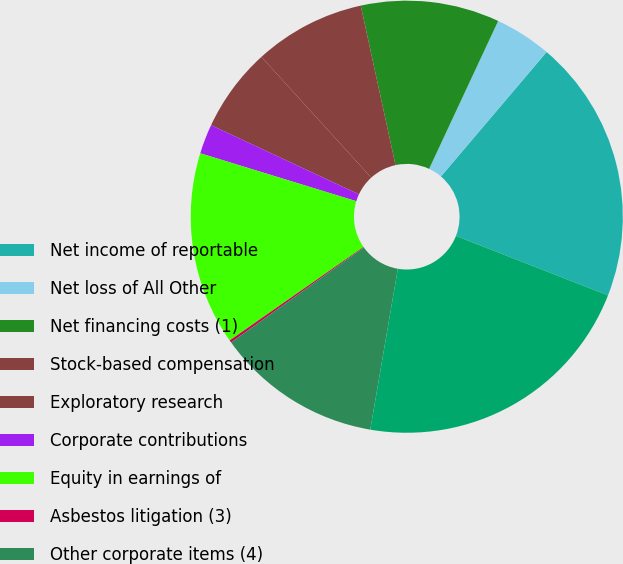<chart> <loc_0><loc_0><loc_500><loc_500><pie_chart><fcel>Net income of reportable<fcel>Net loss of All Other<fcel>Net financing costs (1)<fcel>Stock-based compensation<fcel>Exploratory research<fcel>Corporate contributions<fcel>Equity in earnings of<fcel>Asbestos litigation (3)<fcel>Other corporate items (4)<fcel>Net income<nl><fcel>19.73%<fcel>4.25%<fcel>10.37%<fcel>8.33%<fcel>6.29%<fcel>2.22%<fcel>14.45%<fcel>0.18%<fcel>12.41%<fcel>21.77%<nl></chart> 